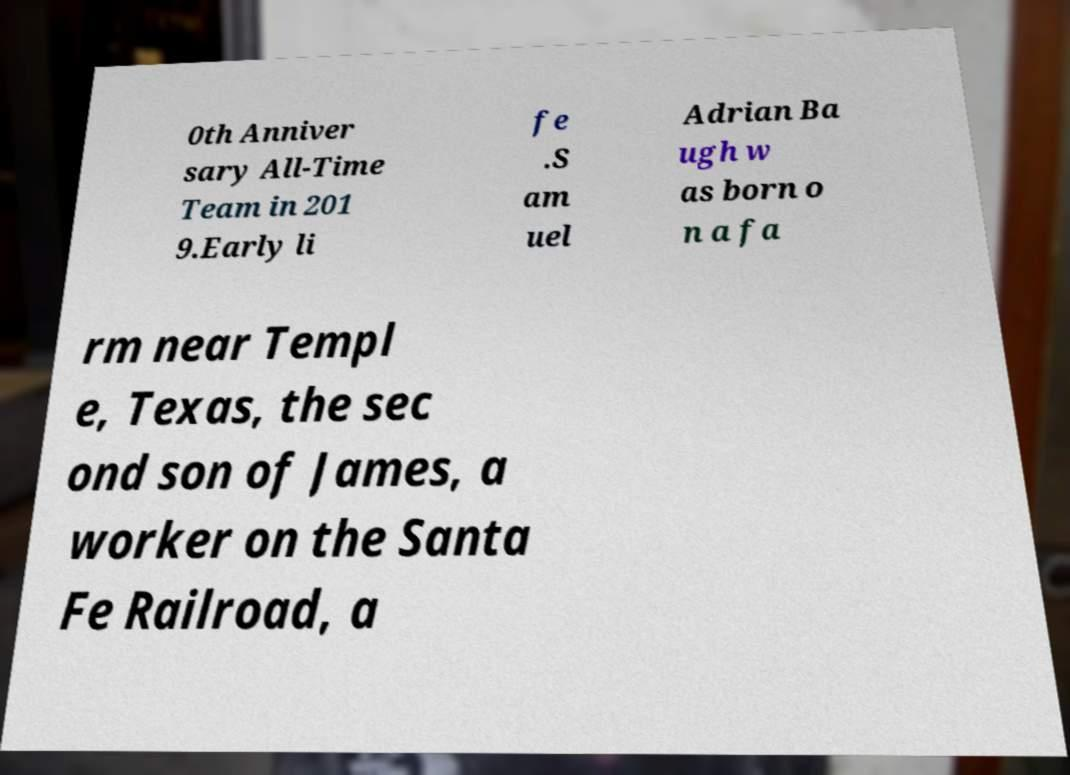Can you read and provide the text displayed in the image?This photo seems to have some interesting text. Can you extract and type it out for me? 0th Anniver sary All-Time Team in 201 9.Early li fe .S am uel Adrian Ba ugh w as born o n a fa rm near Templ e, Texas, the sec ond son of James, a worker on the Santa Fe Railroad, a 